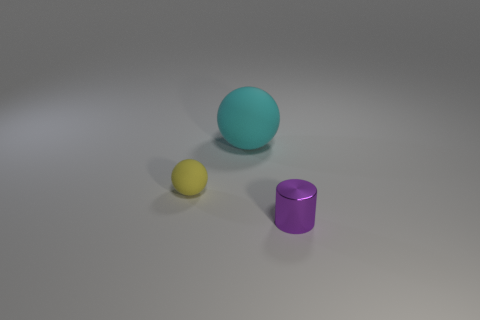Can you describe the texture of the objects and the surface they are on? The objects appear to have a smooth, matte finish, which suggests they are likely made of a material like plastic or painted wood. The surface they rest on seems to have a slight texture, hinting at a fine granularity that could imply it's a matte-finished table or a similar flat surface.  Does the lighting in this image suggest a specific time of day or type of lighting setup? The soft, diffused lighting in the image doesn't strongly suggest any particular time of day. Instead, it seems indicative of artificial studio lighting, neatly designed to minimize harsh shadows and highlight the form of the objects with subtle gradations in tone. 